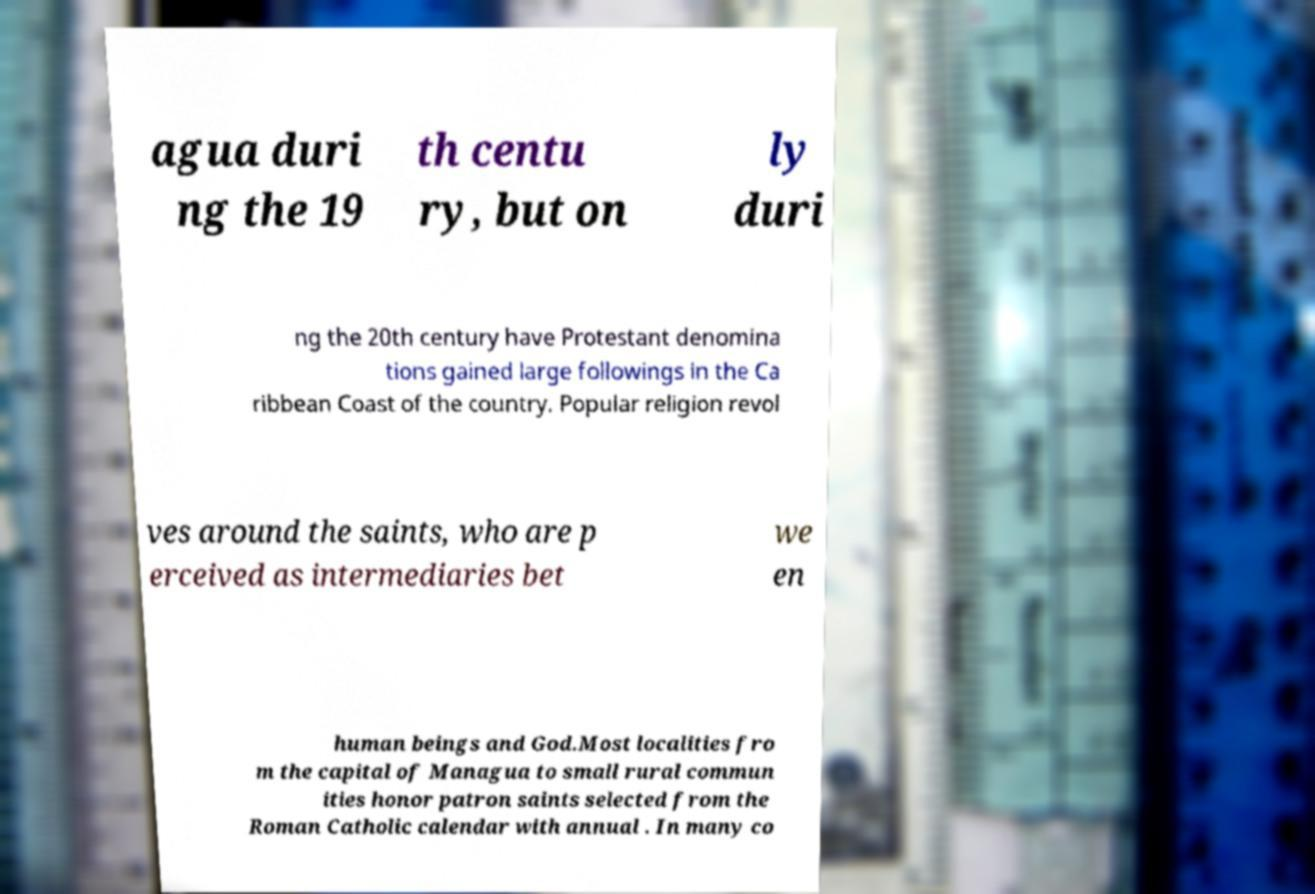Please identify and transcribe the text found in this image. agua duri ng the 19 th centu ry, but on ly duri ng the 20th century have Protestant denomina tions gained large followings in the Ca ribbean Coast of the country. Popular religion revol ves around the saints, who are p erceived as intermediaries bet we en human beings and God.Most localities fro m the capital of Managua to small rural commun ities honor patron saints selected from the Roman Catholic calendar with annual . In many co 